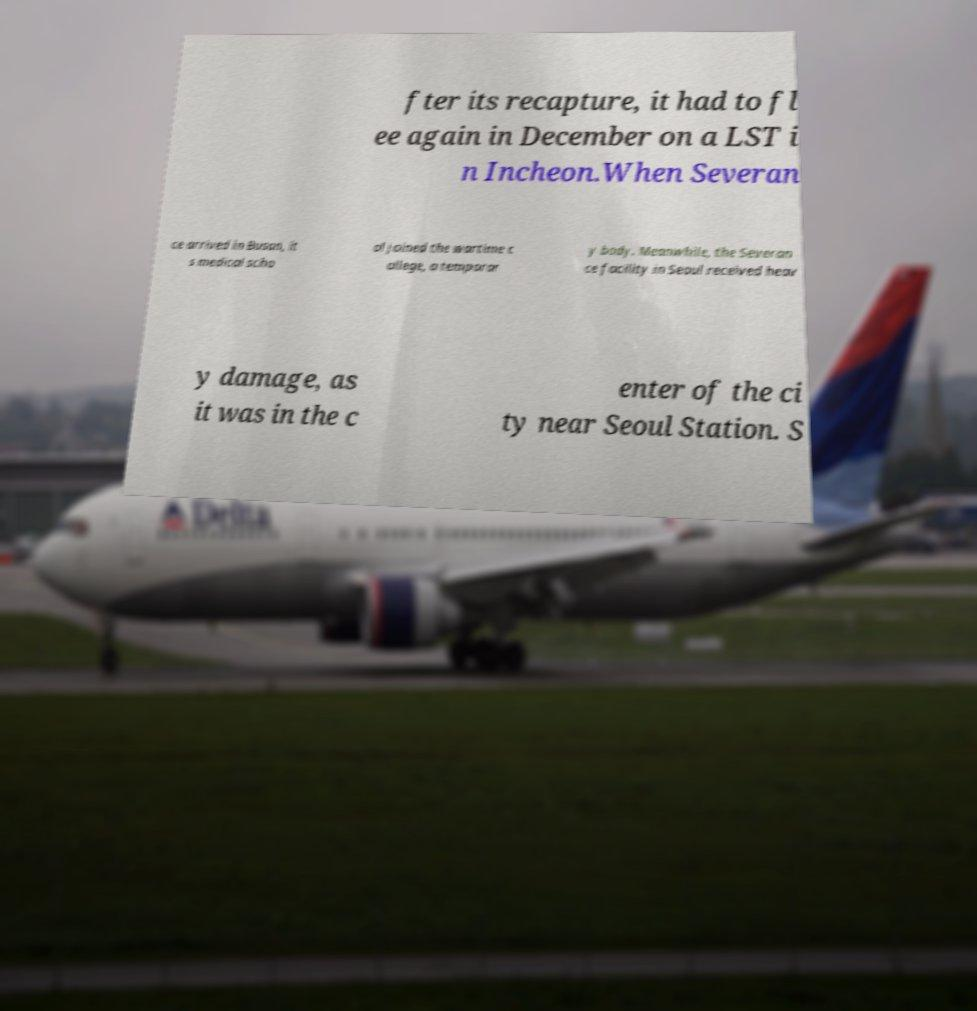What messages or text are displayed in this image? I need them in a readable, typed format. fter its recapture, it had to fl ee again in December on a LST i n Incheon.When Severan ce arrived in Busan, it s medical scho ol joined the wartime c ollege, a temporar y body. Meanwhile, the Severan ce facility in Seoul received heav y damage, as it was in the c enter of the ci ty near Seoul Station. S 